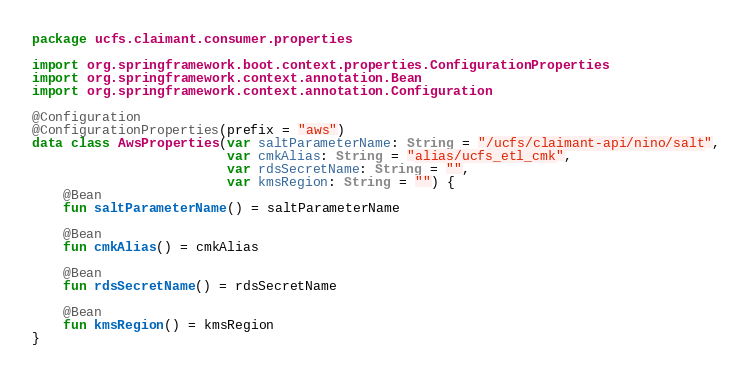<code> <loc_0><loc_0><loc_500><loc_500><_Kotlin_>package ucfs.claimant.consumer.properties

import org.springframework.boot.context.properties.ConfigurationProperties
import org.springframework.context.annotation.Bean
import org.springframework.context.annotation.Configuration

@Configuration
@ConfigurationProperties(prefix = "aws")
data class AwsProperties(var saltParameterName: String = "/ucfs/claimant-api/nino/salt",
                         var cmkAlias: String = "alias/ucfs_etl_cmk",
                         var rdsSecretName: String = "",
                         var kmsRegion: String = "") {
    @Bean
    fun saltParameterName() = saltParameterName

    @Bean
    fun cmkAlias() = cmkAlias

    @Bean
    fun rdsSecretName() = rdsSecretName

    @Bean
    fun kmsRegion() = kmsRegion
}
</code> 